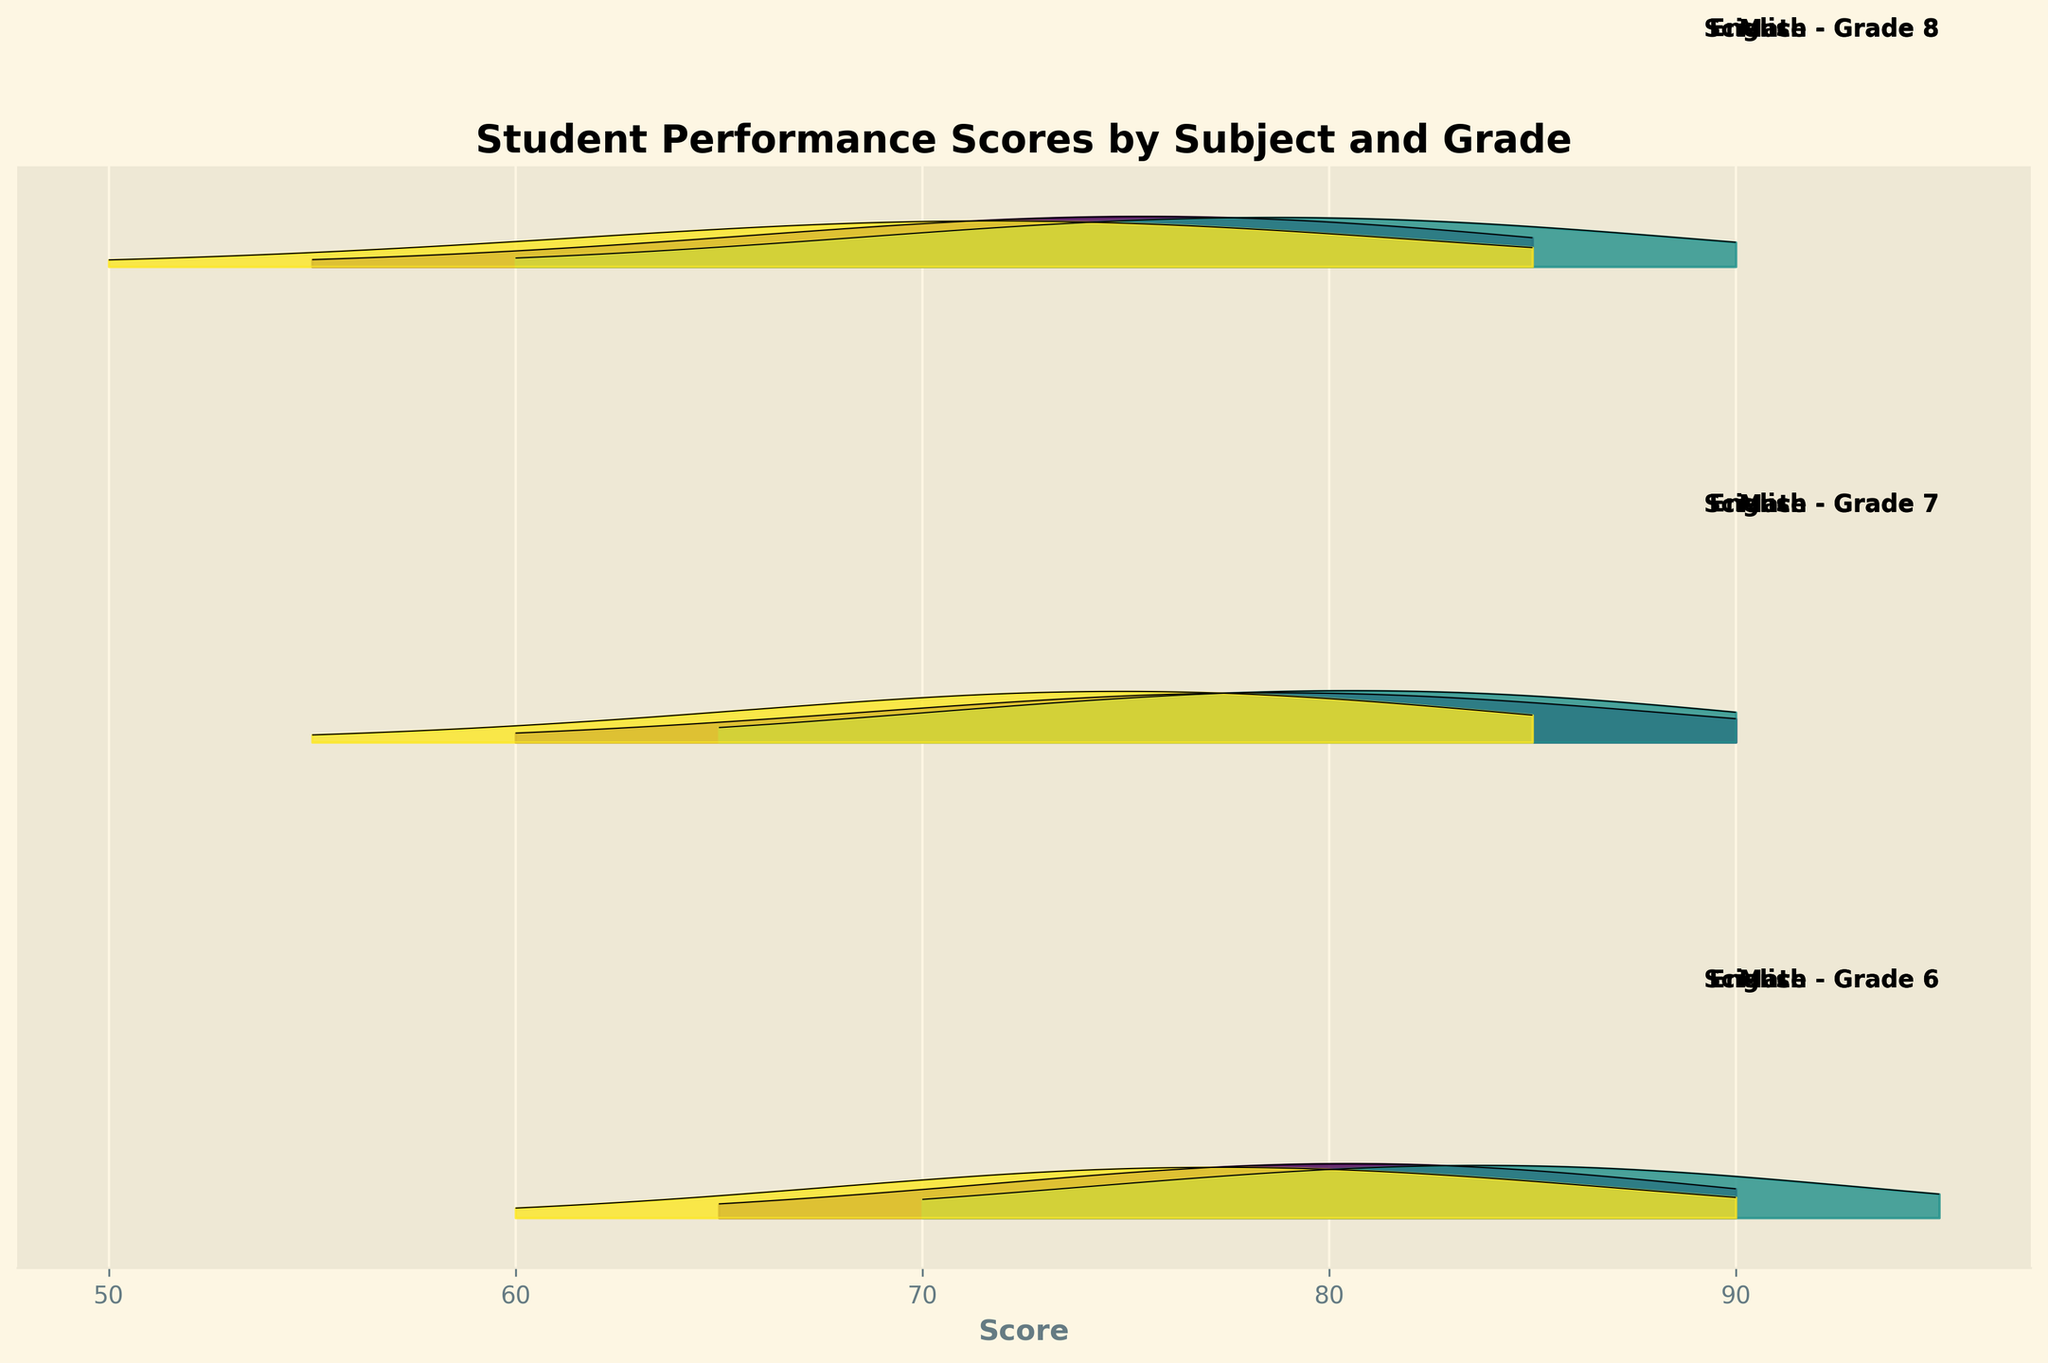What is the title of the figure? The title of the figure is usually displayed at the top of the chart. By looking at the top section of the figure, you find the title which is "Student Performance Scores by Subject and Grade".
Answer: "Student Performance Scores by Subject and Grade" What does the x-axis represent in the figure? The label on the x-axis specifies what is being measured horizontally in the chart. According to the figure, the x-axis is labeled as "Score," indicating student performance scores.
Answer: Score How many subjects are shown in the figure? The different subjects can be identified by their labels and the patterns or colors associated with them in the figure. In this figure, we see "Math," "English," and "Science."
Answer: 3 Which subject and grade combination has the highest density peak? To answer this, you need to observe the highest peaks across all ridgelines in the plot. The highest peak appears for "Science - Grade 7" at around the 75 score mark.
Answer: Science - Grade 7 For Grade 8, which subject has the widest distribution of scores? To determine the widest distribution, we look at the length of the area under the curve for each Grade 8 subject. Science shows the widest spread from a score of 50 to 85.
Answer: Science Do the Math scores increase or decrease with higher grades? By inspecting the ridgelines for Math across grades 6, 7, and 8, we see that the distribution shifts to the left slightly in higher grades, indicating a trend of lower scores.
Answer: Decrease Which subject shows the most consistent performance across all grades? The subject with the least variation in peaks and distribution across all grades would indicate consistent performance. English shows fairly even peaks and similar distributions across all grades.
Answer: English Between English and Math for Grade 6, which subject has a higher density at the 85 score mark? Comparing the heights of the ridgelines at the score of 85 for Grade 6, the ridge for English is higher than the ridge for Math.
Answer: English How does the performance in Science for Grade 8 compare to the performance in Math for Grade 8? Comparing the ridgelines for Science and Math in Grade 8, the peak for Science (centered around scores of 65-70) is higher and wider than the peak for Math (centered around scores of 75-80), suggesting better performance in Science for Grade 8.
Answer: Better performance in Science What grade and subject combination shows the lowest density for a score of 65? To find this, observe where the density is lowest at the 65 score mark across all ridgelines. For Math Grade 7, the density at 65 is very low, almost near zero.
Answer: Math - Grade 7 